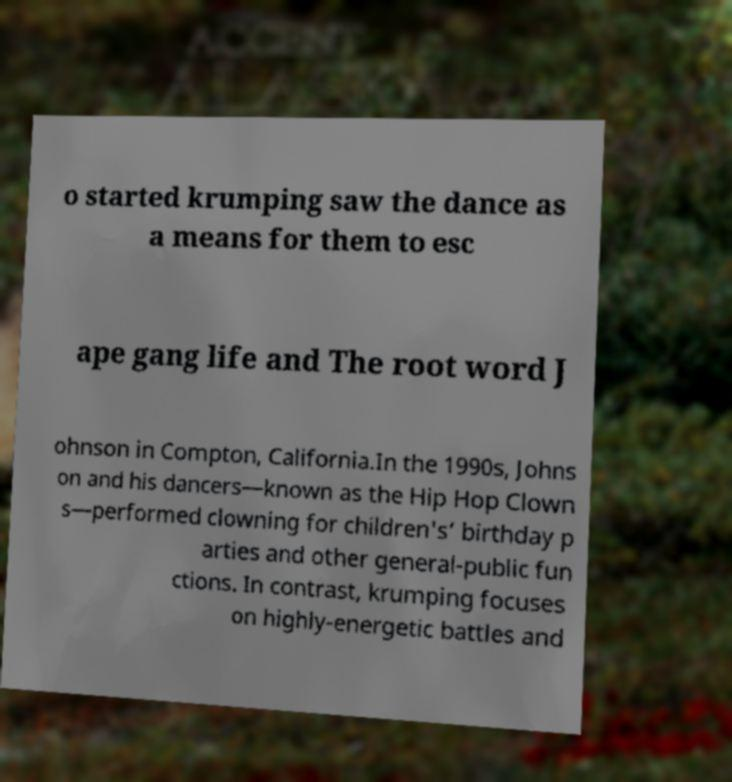Please read and relay the text visible in this image. What does it say? o started krumping saw the dance as a means for them to esc ape gang life and The root word J ohnson in Compton, California.In the 1990s, Johns on and his dancers—known as the Hip Hop Clown s—performed clowning for children's’ birthday p arties and other general-public fun ctions. In contrast, krumping focuses on highly-energetic battles and 